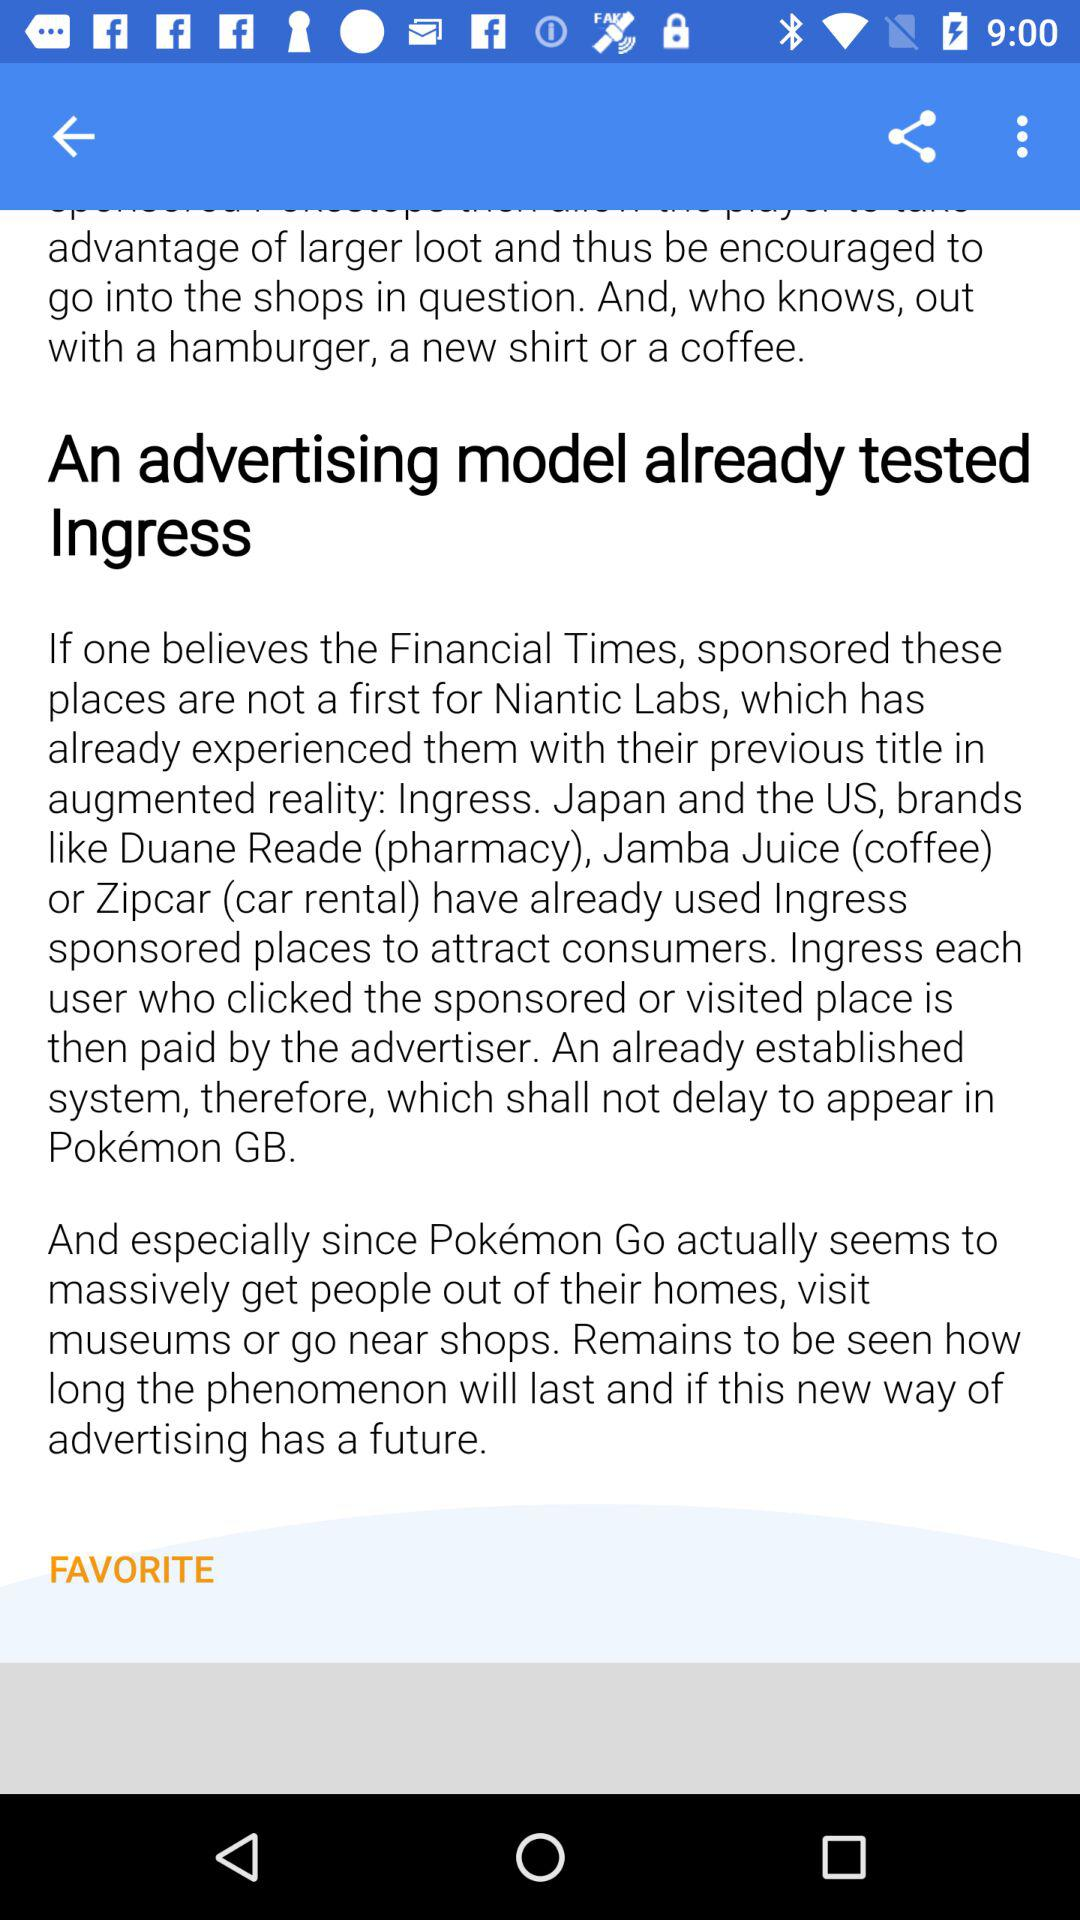How many brands have used sponsored places in Ingress?
Answer the question using a single word or phrase. 3 